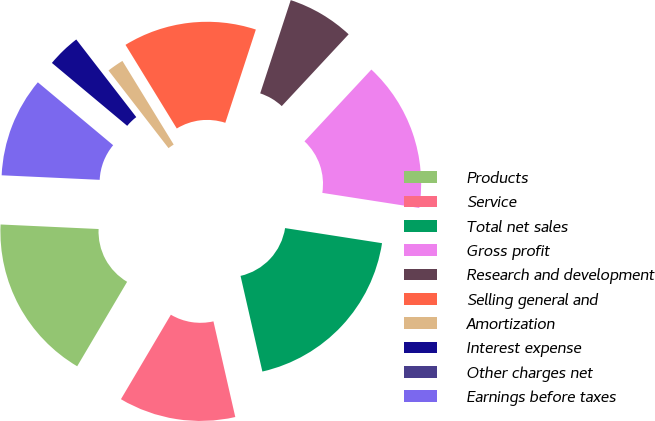Convert chart to OTSL. <chart><loc_0><loc_0><loc_500><loc_500><pie_chart><fcel>Products<fcel>Service<fcel>Total net sales<fcel>Gross profit<fcel>Research and development<fcel>Selling general and<fcel>Amortization<fcel>Interest expense<fcel>Other charges net<fcel>Earnings before taxes<nl><fcel>17.24%<fcel>12.07%<fcel>18.97%<fcel>15.52%<fcel>6.9%<fcel>13.79%<fcel>1.72%<fcel>3.45%<fcel>0.0%<fcel>10.34%<nl></chart> 